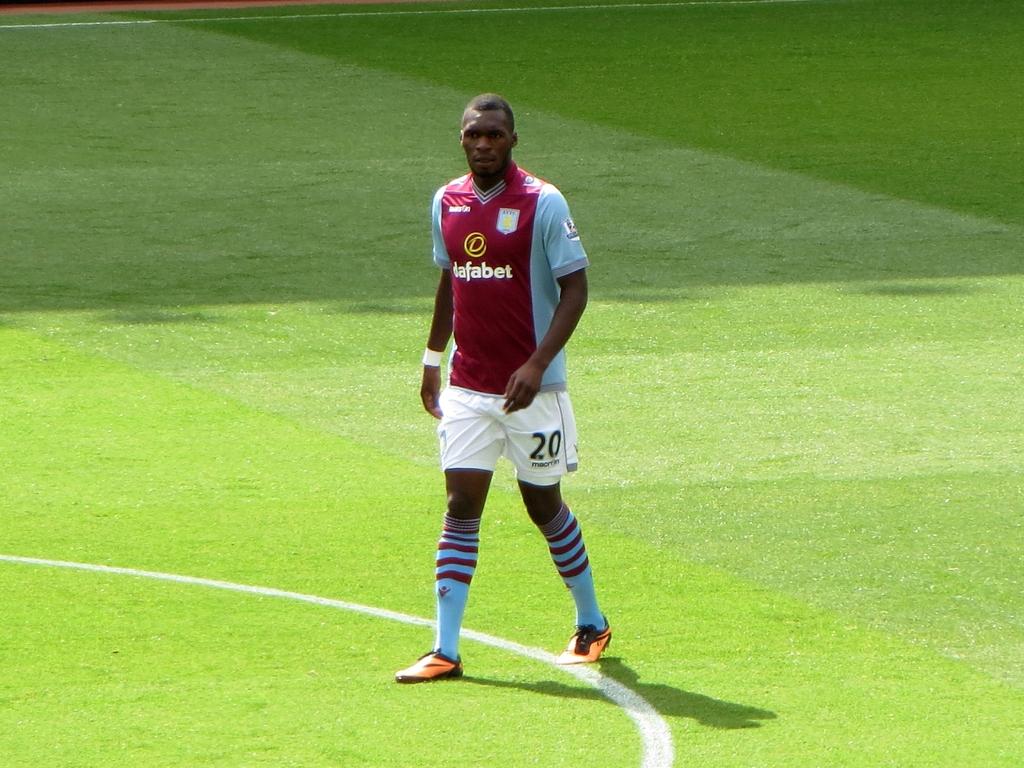What number does it say on the shorts?
Keep it short and to the point. 20. What is the number on the shorts?
Your answer should be very brief. 20. 